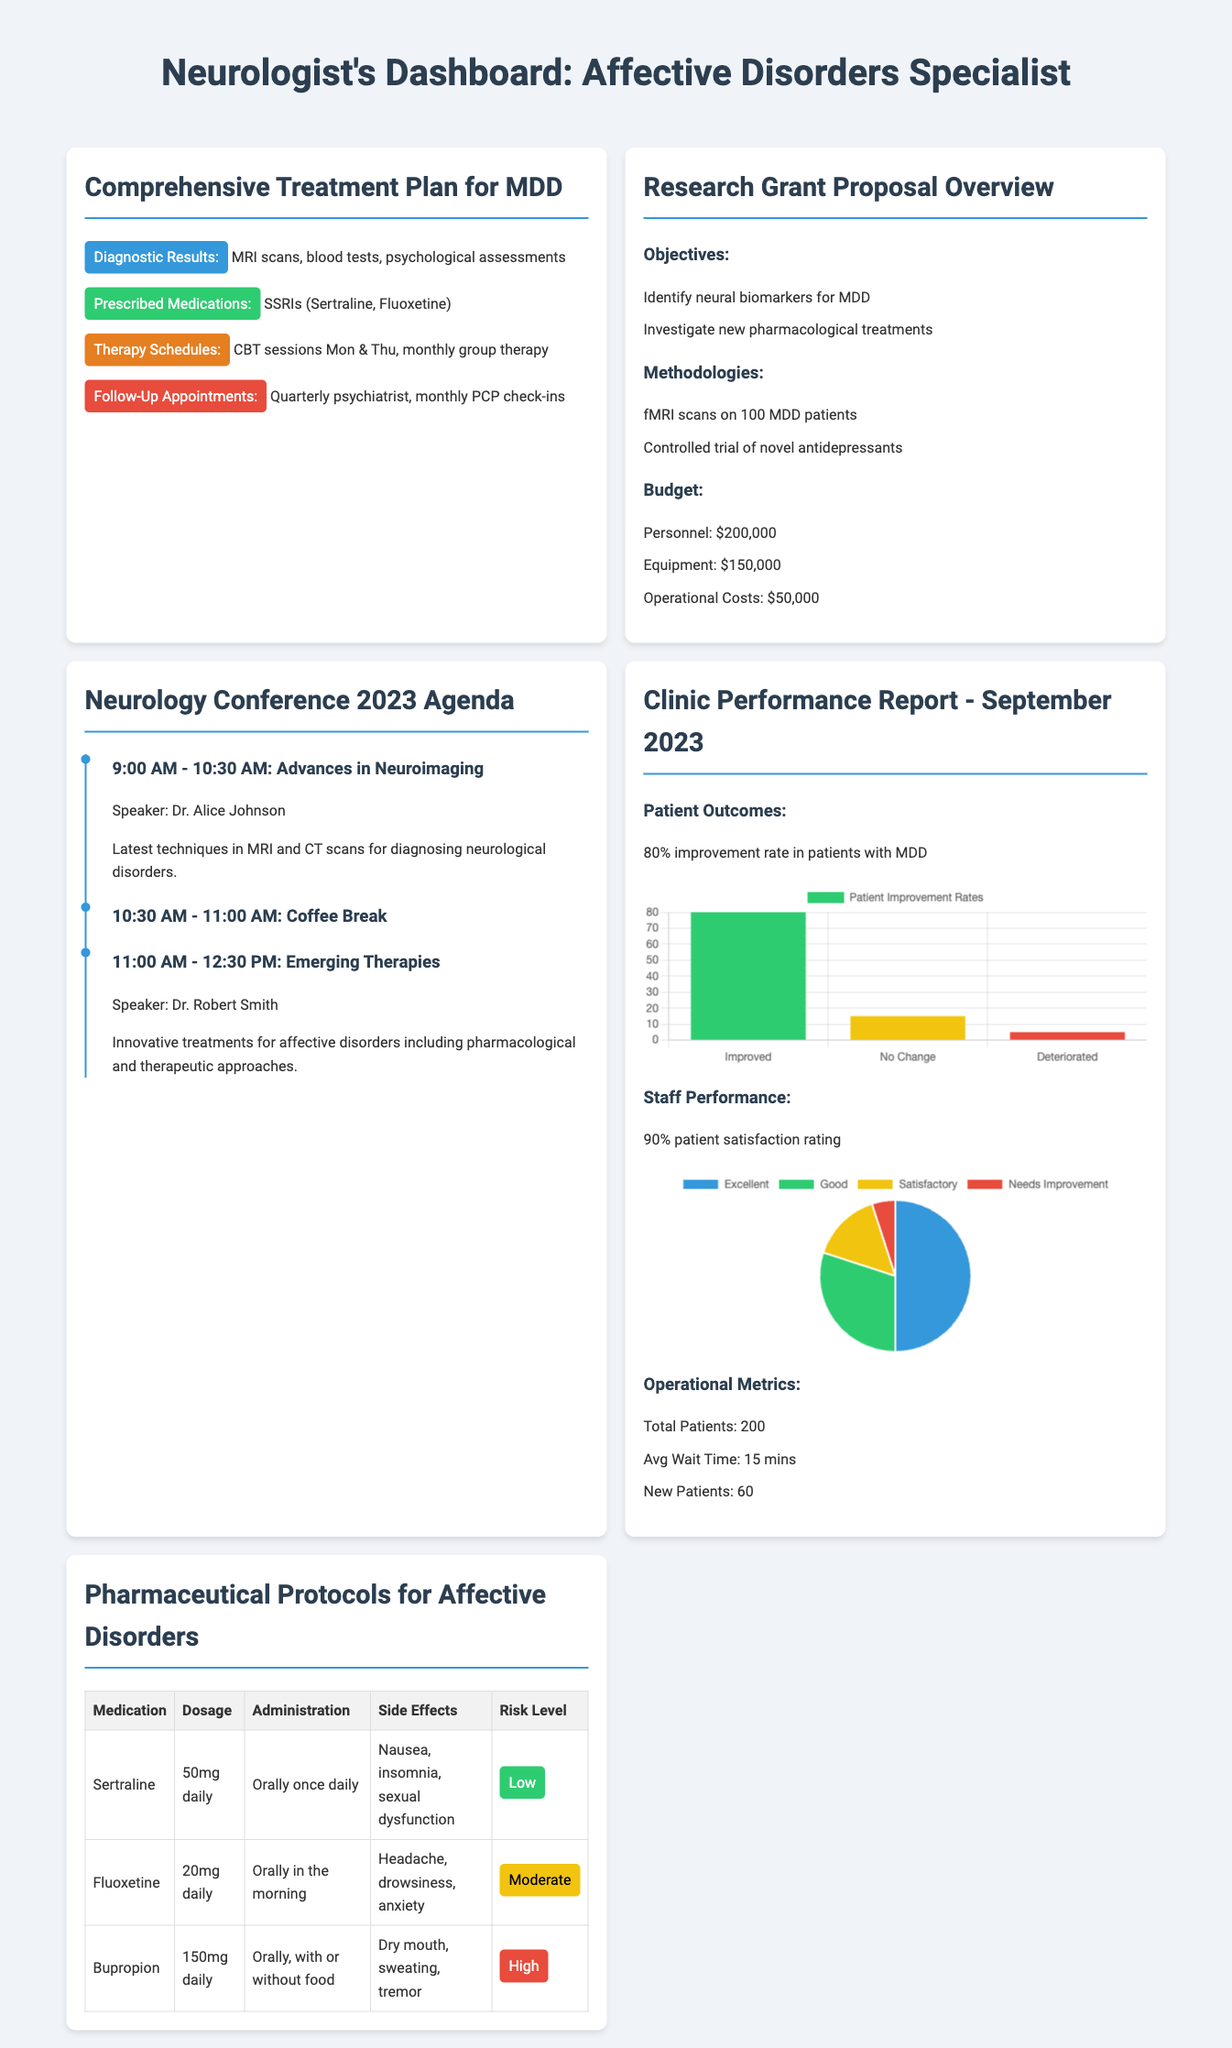What are the prescribed medications for MDD? The prescribed medications are listed in the treatment plan under "Prescribed Medications," which includes SSRIs such as Sertraline and Fluoxetine.
Answer: SSRIs (Sertraline, Fluoxetine) What percentage of patients showed improvement? The patient outcomes section states an 80% improvement rate in patients with MDD.
Answer: 80% What is the duration for follow-up appointments? The treatment plan details the follow-up appointments' frequency, mentioning quarterly psychiatrist visits and monthly PCP check-ins.
Answer: Quarterly and monthly What is the total budget for the research grant proposal? The budget overview specifies three components adding up to the total budget: personnel $200,000, equipment $150,000, and operational costs $50,000.
Answer: $400,000 Who is the speaker for the session on emerging therapies? The agenda lists Dr. Robert Smith as the speaker for the "Emerging Therapies" session.
Answer: Dr. Robert Smith What is the average wait time reported in the clinic performance report? The operational metrics section provides the average wait time spent by patients in the clinic, which is stated clearly.
Answer: 15 mins What type of chart is used for patient improvement rates? The document specifies the type of chart used to illustrate patient outcomes, indicating it is a bar chart.
Answer: Bar chart How many new patients were reported for the month? The operational metrics indicate the number of new patients in the clinic for the month.
Answer: 60 